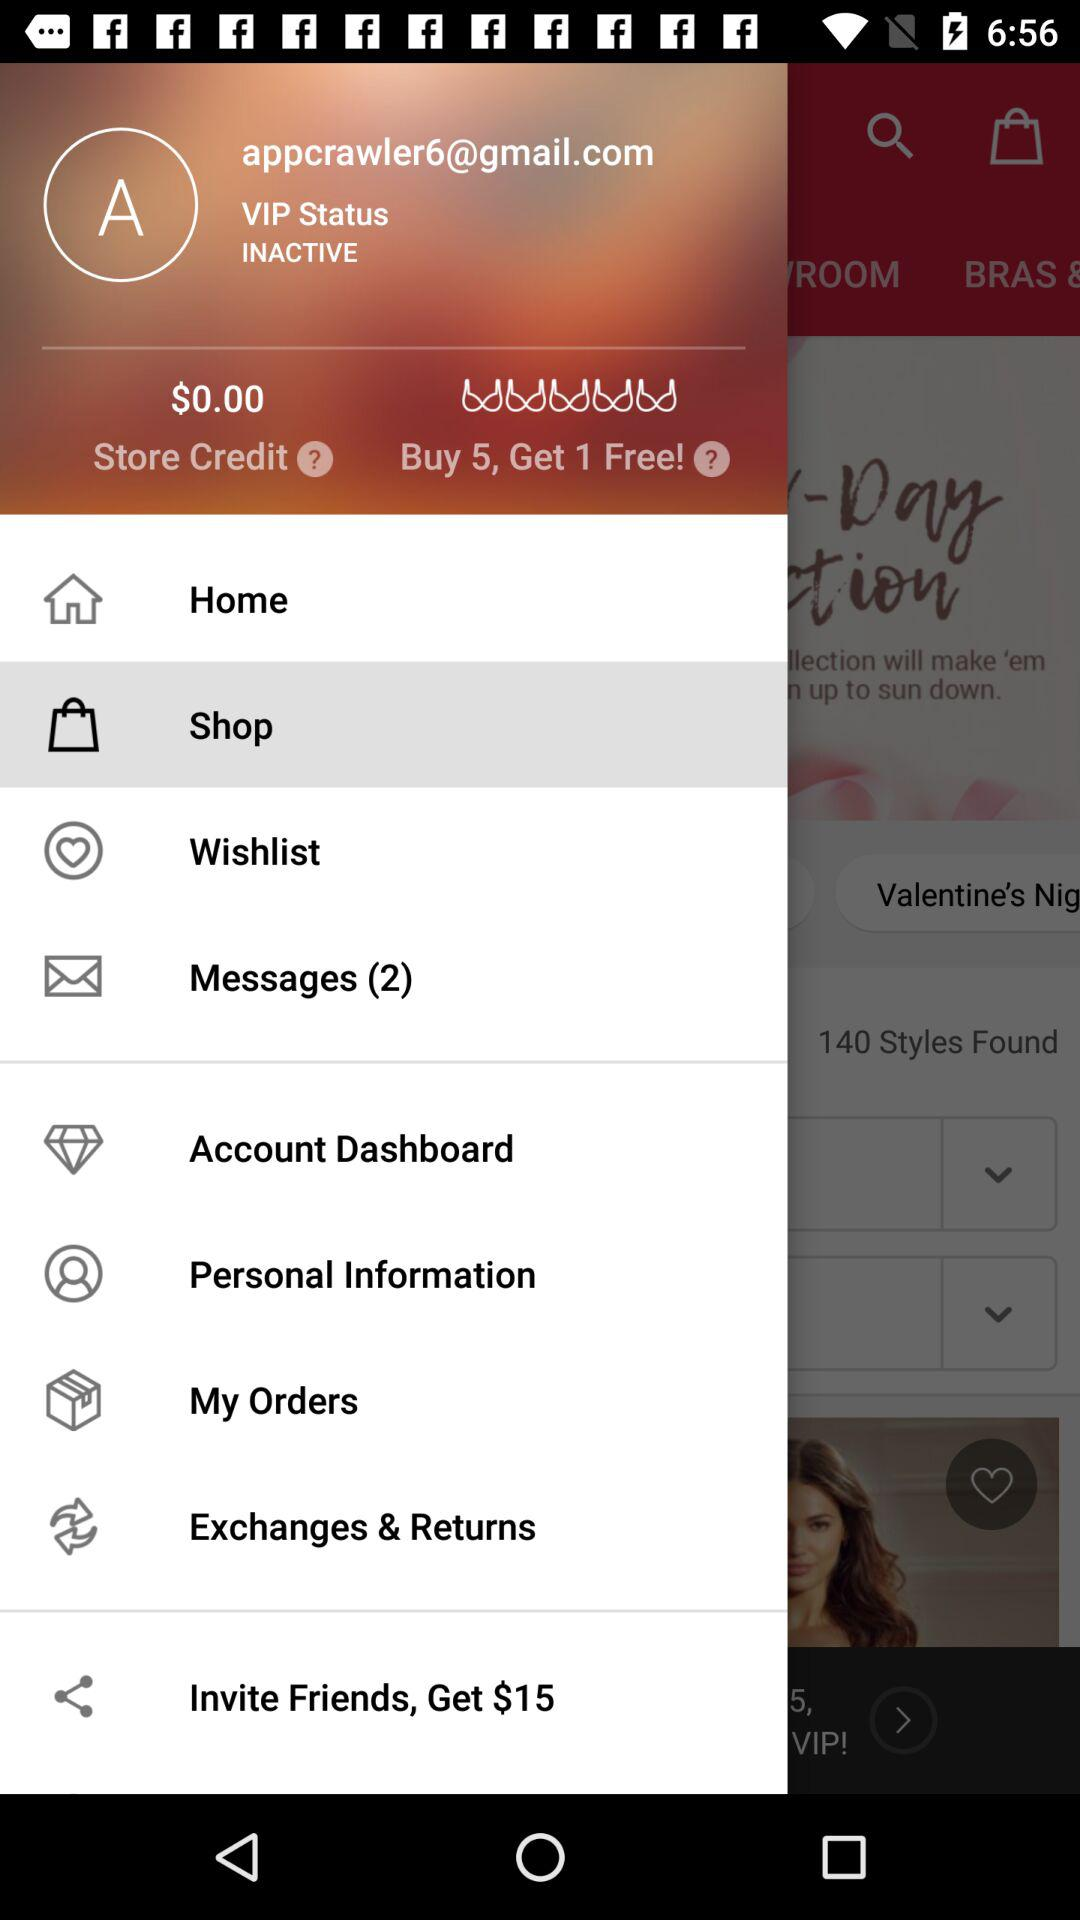How many unread messages are there? There are 2 unread messages. 